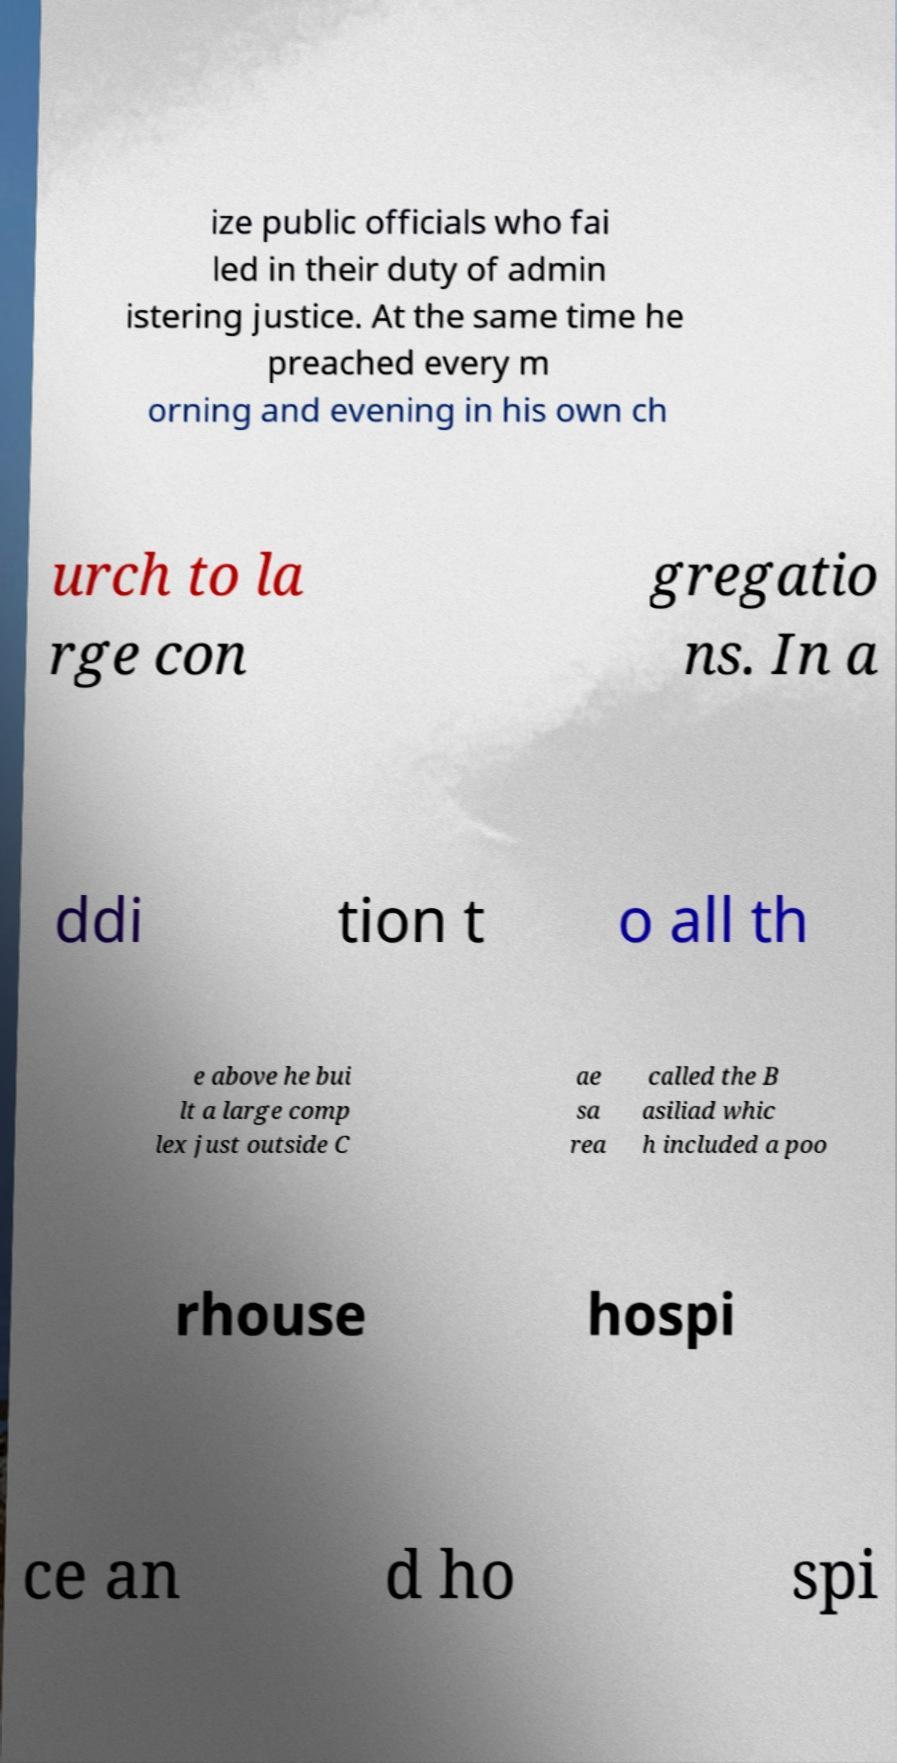What messages or text are displayed in this image? I need them in a readable, typed format. ize public officials who fai led in their duty of admin istering justice. At the same time he preached every m orning and evening in his own ch urch to la rge con gregatio ns. In a ddi tion t o all th e above he bui lt a large comp lex just outside C ae sa rea called the B asiliad whic h included a poo rhouse hospi ce an d ho spi 